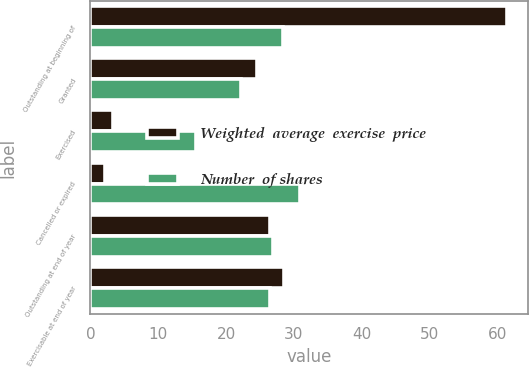Convert chart. <chart><loc_0><loc_0><loc_500><loc_500><stacked_bar_chart><ecel><fcel>Outstanding at beginning of<fcel>Granted<fcel>Exercised<fcel>Cancelled or expired<fcel>Outstanding at end of year<fcel>Exercisable at end of year<nl><fcel>Weighted  average  exercise  price<fcel>61.4<fcel>24.5<fcel>3.3<fcel>2.2<fcel>26.43<fcel>28.6<nl><fcel>Number  of shares<fcel>28.39<fcel>22.2<fcel>15.54<fcel>30.97<fcel>26.96<fcel>26.43<nl></chart> 